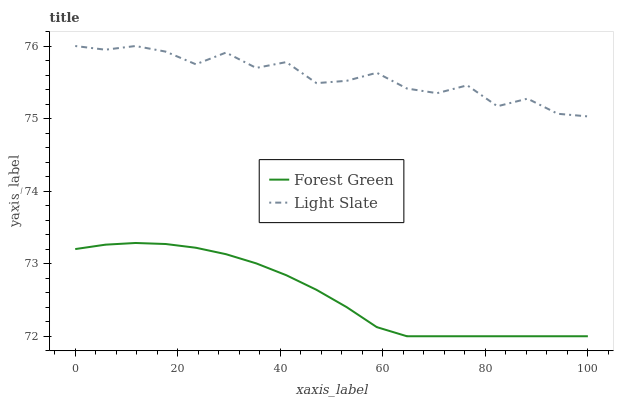Does Forest Green have the minimum area under the curve?
Answer yes or no. Yes. Does Light Slate have the maximum area under the curve?
Answer yes or no. Yes. Does Forest Green have the maximum area under the curve?
Answer yes or no. No. Is Forest Green the smoothest?
Answer yes or no. Yes. Is Light Slate the roughest?
Answer yes or no. Yes. Is Forest Green the roughest?
Answer yes or no. No. Does Light Slate have the highest value?
Answer yes or no. Yes. Does Forest Green have the highest value?
Answer yes or no. No. Is Forest Green less than Light Slate?
Answer yes or no. Yes. Is Light Slate greater than Forest Green?
Answer yes or no. Yes. Does Forest Green intersect Light Slate?
Answer yes or no. No. 